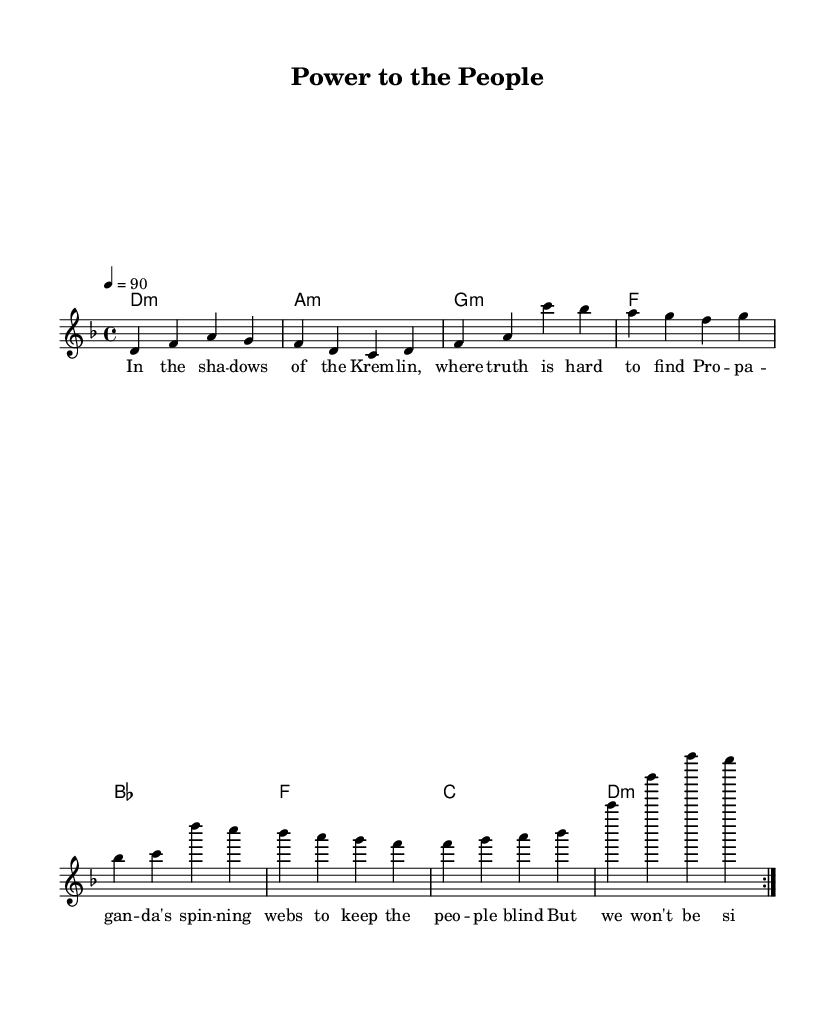What is the key signature of this music? The key signature is indicated at the beginning of the staff and shows D minor, which has one flat (B flat).
Answer: D minor What is the time signature of this music? The time signature is found at the start of the music and is represented as 4/4, meaning there are four beats in each measure.
Answer: 4/4 What is the tempo of the piece? The tempo is specified above the staff, indicating a speed of 90 beats per minute, which means the quarter note gets the beat.
Answer: 90 How many times is the verse repeated? The verse notation has a repeat indication (volta) stating that it should be played two times before proceeding.
Answer: 2 What are the first two words of the verse lyrics? The first two words of the verse lyrics can be found at the beginning of the lyric section and are "In the."
Answer: In the Which chord accompanies the chorus first? The chord notation at the beginning of the chorus shows that the first chord is B flat major, which supports the melody during this section.
Answer: B flat What is the overall theme reflected in the lyrics? The lyrics express a theme of resistance against oppression and the call for empowerment, which aligns with the socio-political critique intended in the song.
Answer: Empowerment 